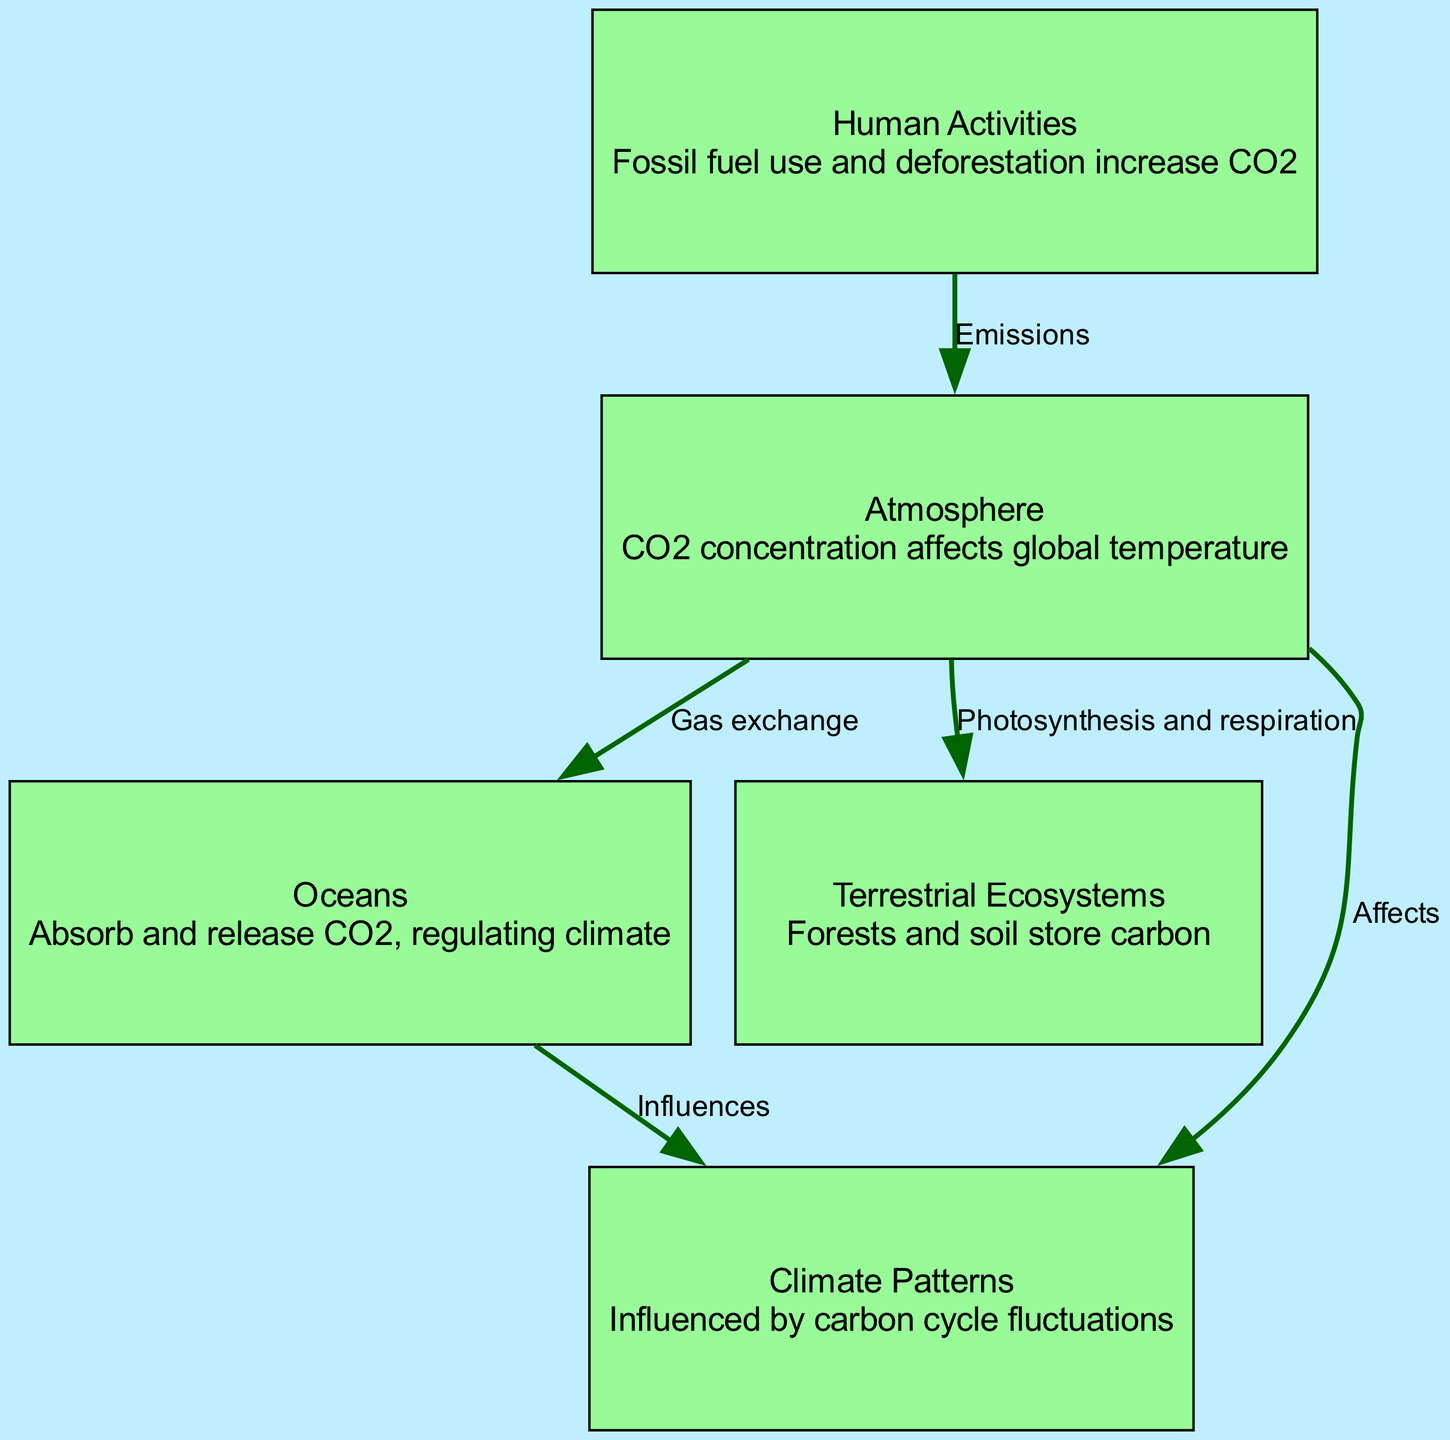What is the total number of nodes in the diagram? The nodes listed in the diagram are: Atmosphere, Oceans, Terrestrial Ecosystems, Human Activities, and Climate Patterns. Counting them gives a total of 5 nodes.
Answer: 5 Which node represents the process of CO2 absorption? The Oceans node is described as "Absorb and release CO2, regulating climate," indicating that it is responsible for the absorption of CO2.
Answer: Oceans What is the relationship between Atmosphere and Climate Patterns? The edge from Atmosphere to Climate Patterns is labeled "Affects," which specifies that the concentration of CO2 in the Atmosphere has an influence on Climate Patterns.
Answer: Affects How many edges connect the Atmosphere to other nodes? The edges from the Atmosphere are: one to the Oceans (Gas exchange), one to Terrestrial Ecosystems (Photosynthesis and respiration), and one to Climate Patterns (Affects). So, there are three edges connected to the Atmosphere.
Answer: 3 What human activity increases CO2 in the Atmosphere? The Human Activities node describes actions such as "Fossil fuel use and deforestation," which directly contribute to increased CO2 levels in the Atmosphere.
Answer: Fossil fuel use and deforestation Which node influences Climate Patterns through the Oceans? The edge from Oceans to Climate Patterns is labeled "Influences," meaning that the Oceans play a significant role in influencing Climate Patterns as part of the carbon cycle.
Answer: Oceans Explain the indirect relationship between Human Activities and Climate Patterns. Human Activities increase CO2 in the Atmosphere, as shown by the edge labeled "Emissions." This increase in CO2 affects Climate Patterns, represented by the edge from Atmosphere to Climate Patterns labeled "Affects." Therefore, the connection exists through the intermediate influence of the Atmosphere.
Answer: Indirectly through Atmosphere Which process connects Terrestrial Ecosystems to the Atmosphere? The relationship described between Terrestrial Ecosystems and the Atmosphere is through the processes of "Photosynthesis and respiration," indicating a direct interaction between these two nodes.
Answer: Photosynthesis and respiration 